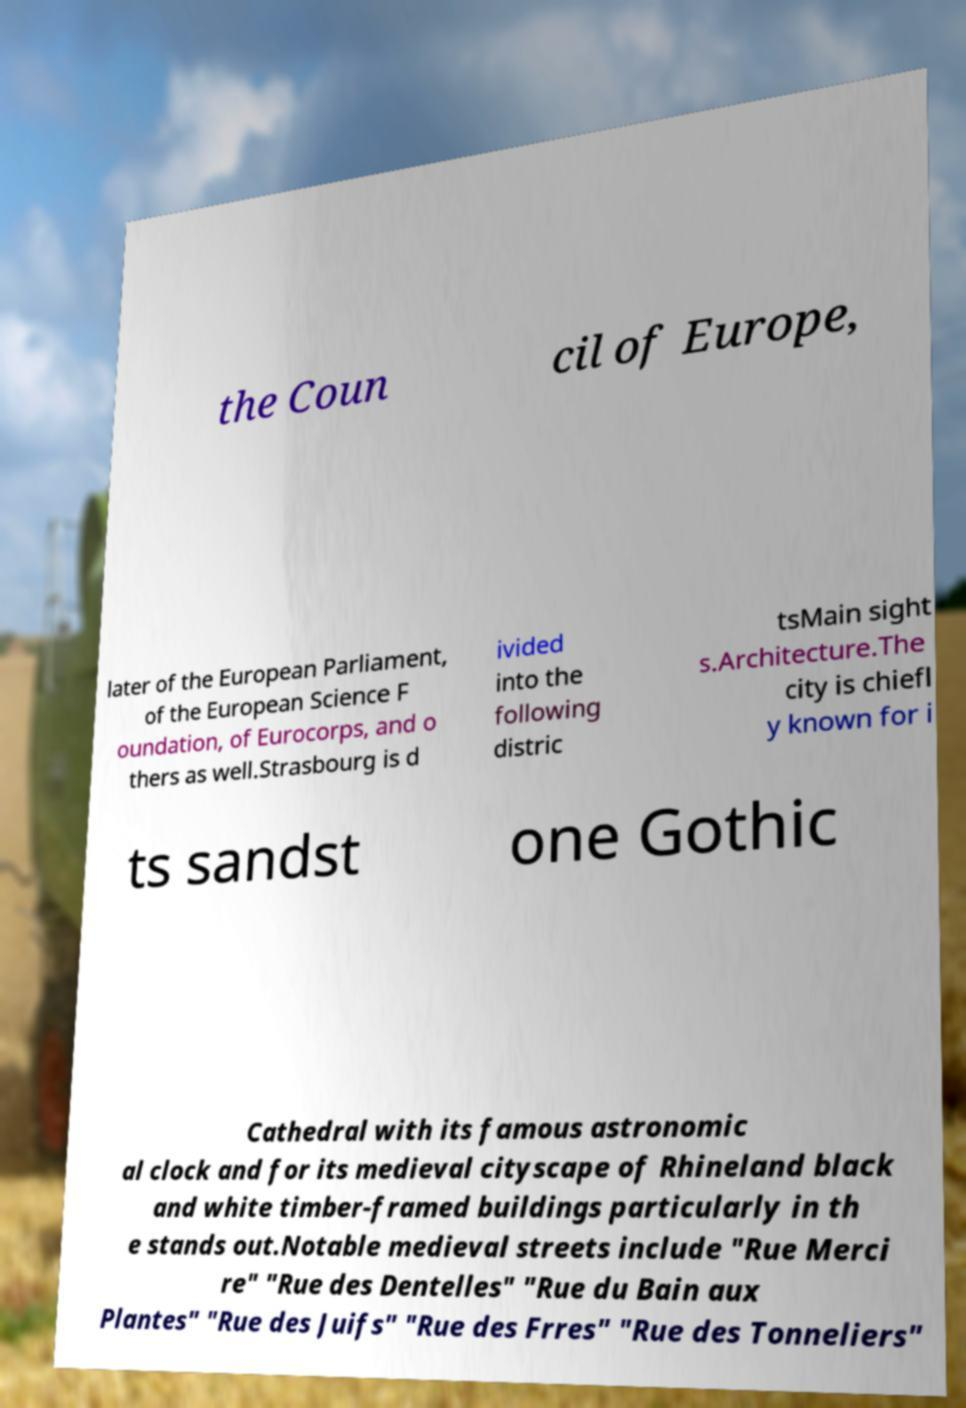Please read and relay the text visible in this image. What does it say? the Coun cil of Europe, later of the European Parliament, of the European Science F oundation, of Eurocorps, and o thers as well.Strasbourg is d ivided into the following distric tsMain sight s.Architecture.The city is chiefl y known for i ts sandst one Gothic Cathedral with its famous astronomic al clock and for its medieval cityscape of Rhineland black and white timber-framed buildings particularly in th e stands out.Notable medieval streets include "Rue Merci re" "Rue des Dentelles" "Rue du Bain aux Plantes" "Rue des Juifs" "Rue des Frres" "Rue des Tonneliers" 